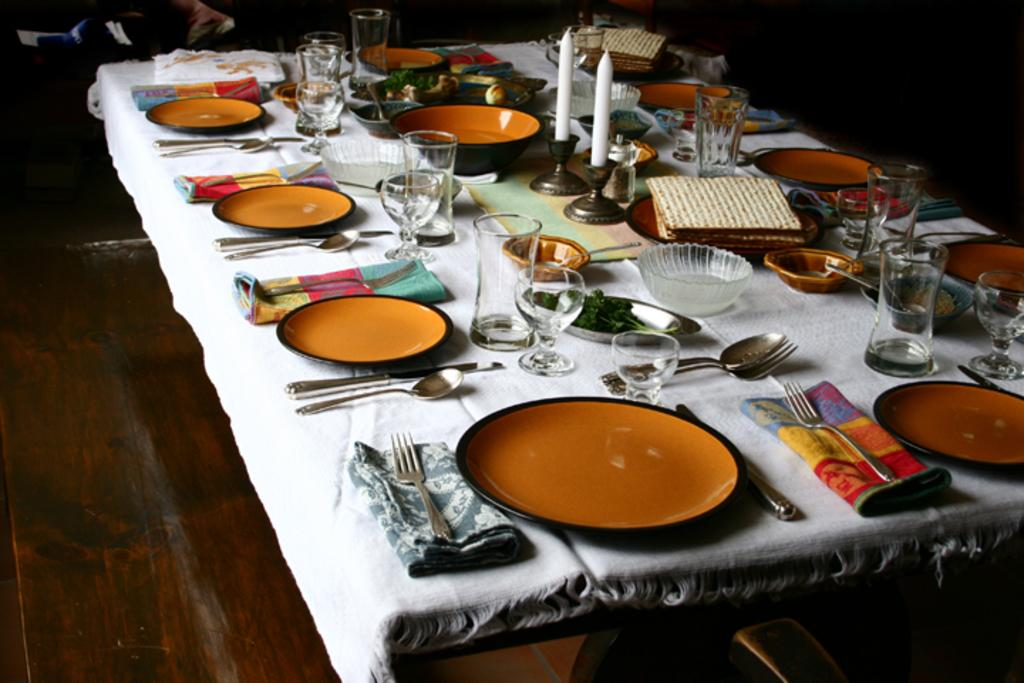What type of furniture is in the image? There is a dining table in the image. How is the dining table decorated? The dining table is covered with a white cloth. What types of tableware are on the table? There are plates, spoons, forks, bowls, glasses, and candles on the table. What might be used for cleaning or wiping in the image? Napkins are present on the table. What type of education is being provided at the table in the image? There is no indication of education being provided in the image; it features a dining table with various tableware and accessories. 